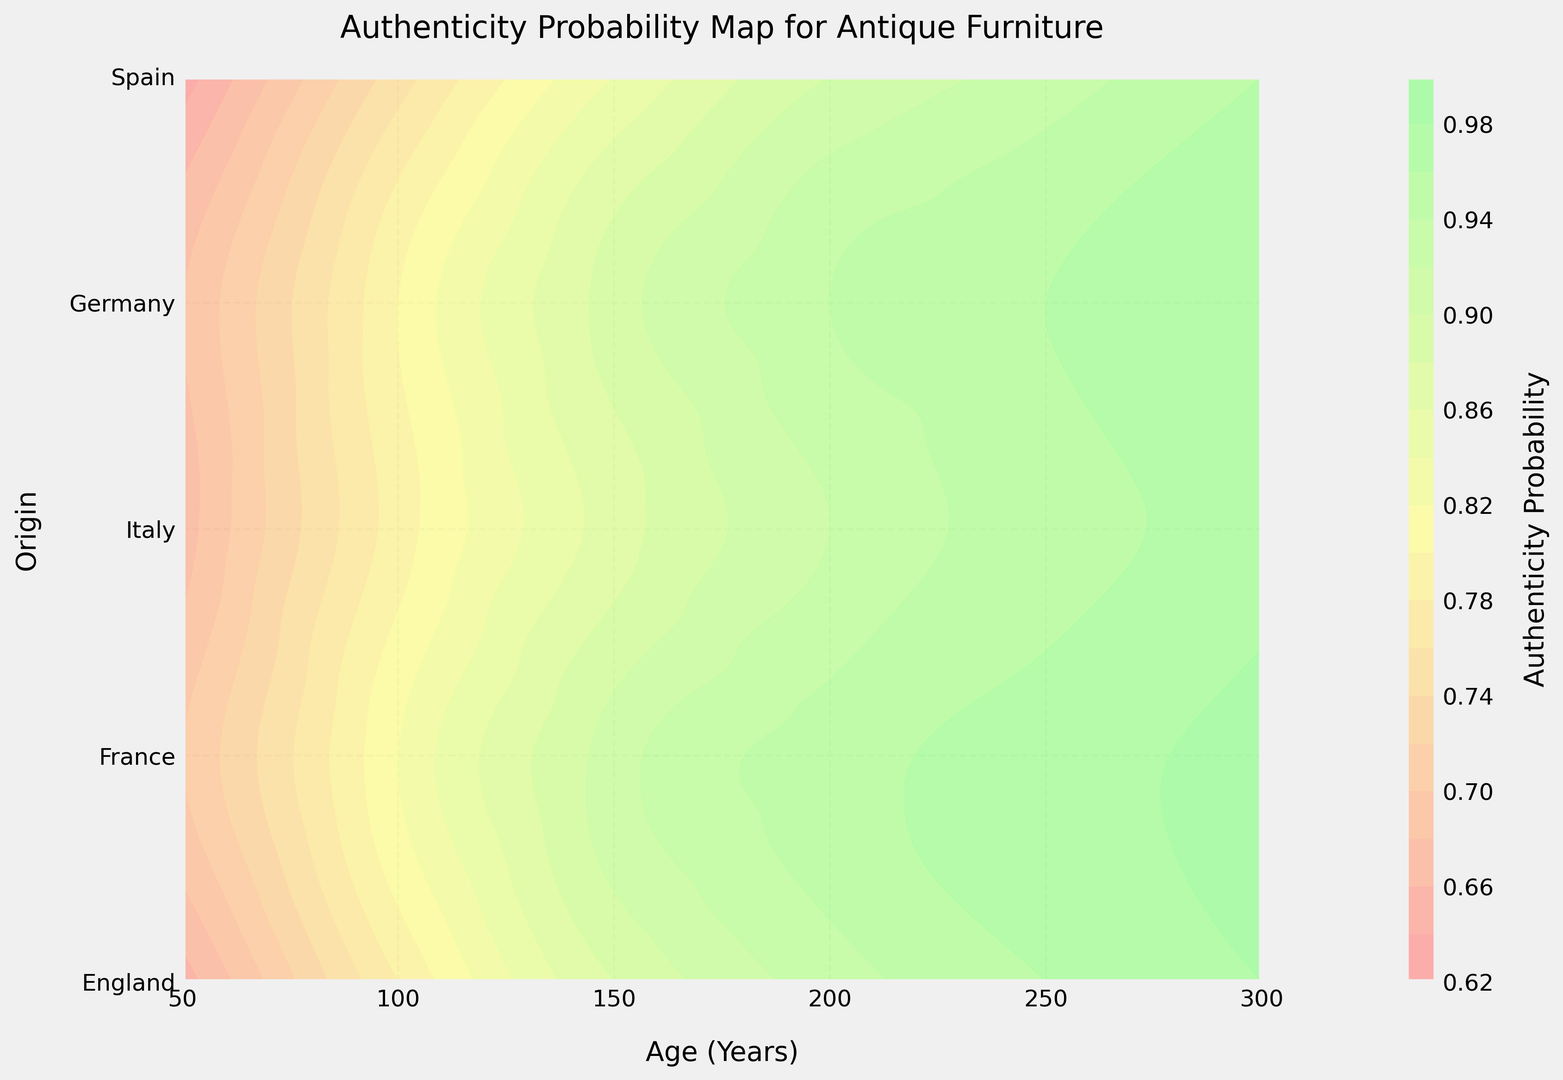What's the highest authenticity probability for furniture aged 150 years across all origins? Observe the contour lines at age 150 and check for the highest probability value among origins (England, France, Italy, Germany, Spain). The highest contour color corresponds to France at 0.91.
Answer: 0.91 How does the authenticity probability for English furniture change as it ages from 50 to 300 years? Trace the contour lines corresponding to English origin as age increases from 50 to 300. The probability increases from 0.65 at age 50 to 0.98 at age 300.
Answer: Increases Which origin has the lowest authenticity probability for furniture aged 200 years? Examine the contour lines at age 200 and find the lowest probability value among origins. The contour color shows Spain has the lowest probability at 0.90.
Answer: Spain Between England and Italy, which origin shows a higher authenticity probability for furniture aged 100 years? Compare the corresponding contour levels for England and Italy at age 100. England has a probability of 0.78 and Italy has 0.80.
Answer: Italy For furniture aged 250 years, how does the authenticity probability for Germany compare to that of Spain? Look at the contour lines at age 250 for Germany and Spain. Germany has a probability of 0.95, and Spain has 0.93.
Answer: Germany is higher What is the difference in authenticity probability between French and German furniture aged 300 years? Check the contour levels for France and Germany at age 300. France has a probability of 0.99 and Germany has 0.97. The difference is 0.99 - 0.97.
Answer: 0.02 Which age range shows the most significant increase in authenticity probability for Spanish furniture? Trace the Spanish contour line and observe where the steepest slope occurs. The authenticity probability notably increases between 150 to 200 years.
Answer: 150 to 200 years 